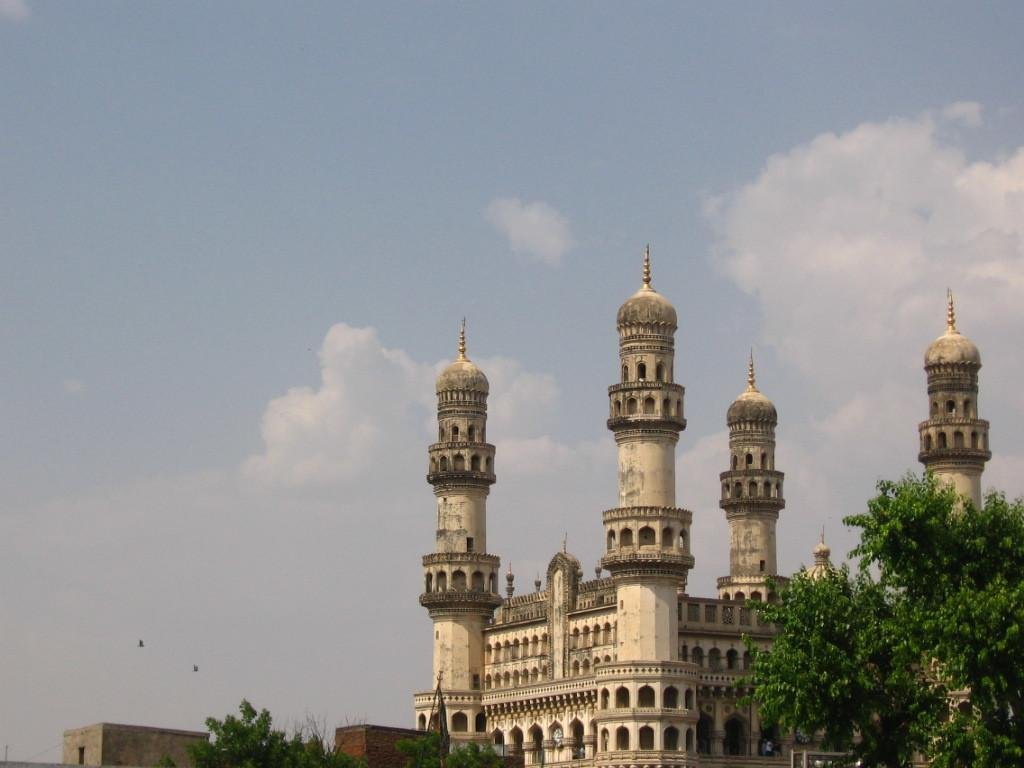What is the main subject on the right side of the image? There is a monument on the right side of the image. What else can be seen in the right bottom corner of the image? There is a tree in the right bottom corner of the image. What is visible at the top of the image? The sky is visible at the top of the image. How many rings are hanging from the branches of the tree in the image? There are no rings hanging from the branches of the tree in the image. Can you see a snake slithering around the monument in the image? There is no snake present in the image. 